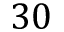Convert formula to latex. <formula><loc_0><loc_0><loc_500><loc_500>3 0</formula> 